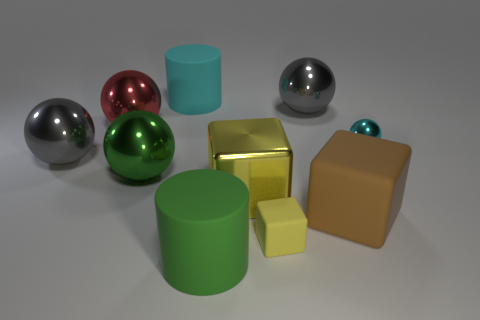There is a big brown thing that is the same material as the tiny yellow block; what shape is it?
Ensure brevity in your answer.  Cube. Is the material of the yellow block that is to the left of the tiny yellow matte object the same as the green cylinder?
Your response must be concise. No. How many other things are made of the same material as the large green sphere?
Provide a short and direct response. 5. What number of things are either cubes left of the big rubber cube or metal things to the left of the large red object?
Ensure brevity in your answer.  3. There is a green thing that is behind the yellow rubber block; is its shape the same as the big matte object that is to the left of the big green cylinder?
Make the answer very short. No. The green matte object that is the same size as the red shiny object is what shape?
Your answer should be compact. Cylinder. What number of matte things are either tiny red cylinders or big gray spheres?
Offer a terse response. 0. Do the gray thing that is behind the small sphere and the red ball behind the small metal ball have the same material?
Keep it short and to the point. Yes. There is a large cube that is the same material as the tiny ball; what color is it?
Make the answer very short. Yellow. Is the number of brown things right of the brown block greater than the number of matte cylinders behind the cyan metal object?
Your answer should be compact. No. 